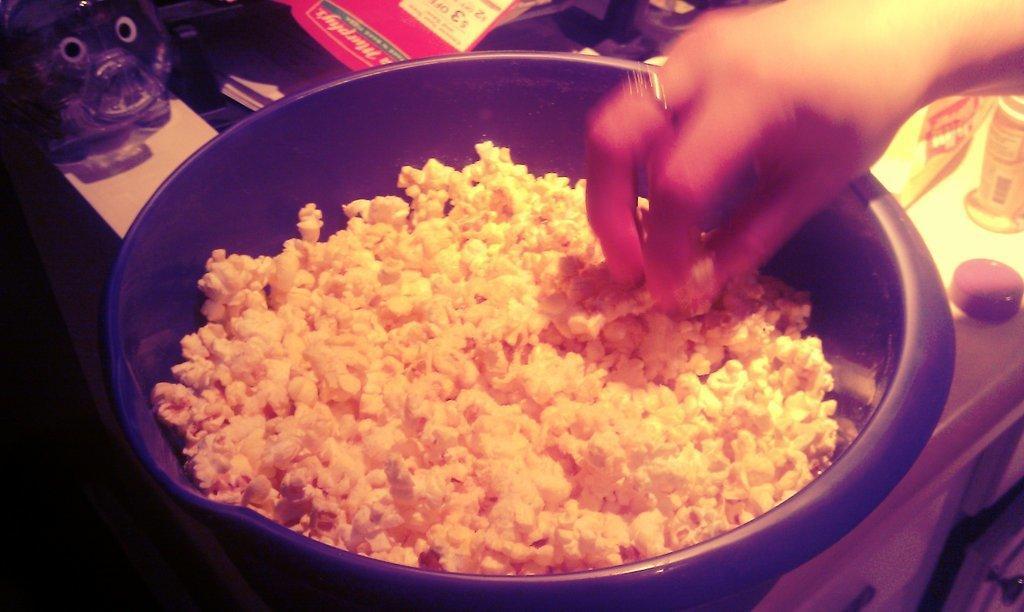Could you give a brief overview of what you see in this image? In this image I can see the bowl with food. To the side I can see the papers, you and many objects. These are on the surface. I can see one person is holding the food. 